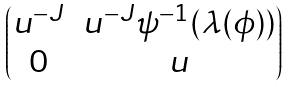Convert formula to latex. <formula><loc_0><loc_0><loc_500><loc_500>\begin{pmatrix} u ^ { - J } & u ^ { - J } \psi ^ { - 1 } ( \lambda ( \phi ) ) \\ 0 & u \end{pmatrix}</formula> 